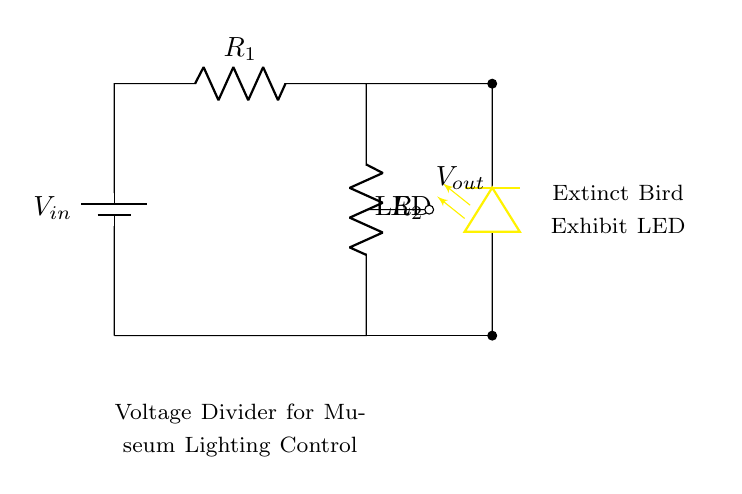What is the function of this circuit? The circuit serves as a voltage divider that controls the brightness of the LED by adjusting the output voltage.
Answer: Voltage divider What is the value of the output voltage near the LED? The output voltage, or Vout, is dependent on the resistor values, but it is shown in the diagram as a marked point. Thus it's defined as Vout.
Answer: Vout How many resistors are in the circuit? There are two resistors in the circuit labeled as R1 and R2, which form the voltage divider.
Answer: Two What color is the LED used in the circuit? The LED in the circuit is colored yellow, as indicated by the label on the diagram.
Answer: Yellow What happens if R1 is increased? Increasing R1 will reduce the output voltage (Vout), leading to a dimmer LED but not directly listed in the diagram.
Answer: Dimmer LED What does the symbol near the power source indicate? The symbol indicates a battery, which is providing the input voltage to the circuit.
Answer: Battery Which component adjusts the brightness of the LED? The brightness of the LED is adjusted by the combined effect of resistors R1 and R2, acting as a voltage divider to modify the output voltage.
Answer: Resistors 